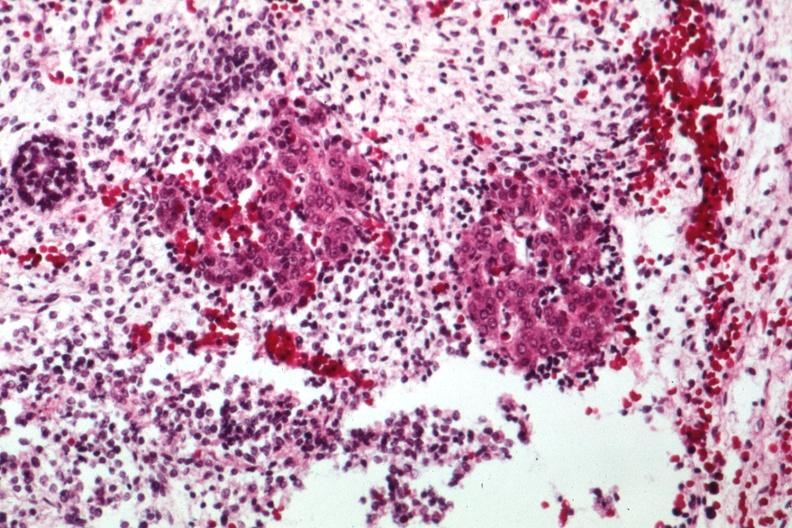s carcinomatosis endometrium primary present?
Answer the question using a single word or phrase. No 